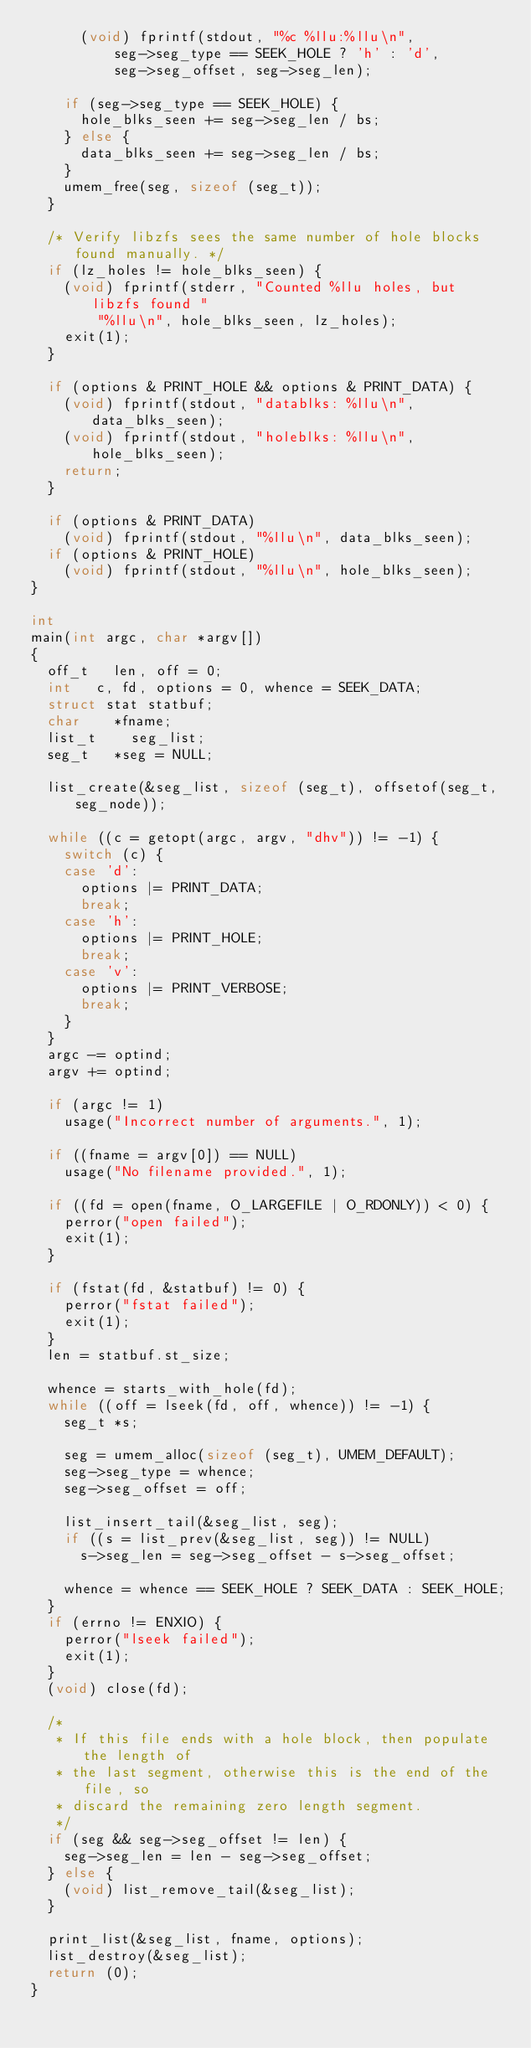<code> <loc_0><loc_0><loc_500><loc_500><_C_>			(void) fprintf(stdout, "%c %llu:%llu\n",
			    seg->seg_type == SEEK_HOLE ? 'h' : 'd',
			    seg->seg_offset, seg->seg_len);

		if (seg->seg_type == SEEK_HOLE) {
			hole_blks_seen += seg->seg_len / bs;
		} else {
			data_blks_seen += seg->seg_len / bs;
		}
		umem_free(seg, sizeof (seg_t));
	}

	/* Verify libzfs sees the same number of hole blocks found manually. */
	if (lz_holes != hole_blks_seen) {
		(void) fprintf(stderr, "Counted %llu holes, but libzfs found "
		    "%llu\n", hole_blks_seen, lz_holes);
		exit(1);
	}

	if (options & PRINT_HOLE && options & PRINT_DATA) {
		(void) fprintf(stdout, "datablks: %llu\n", data_blks_seen);
		(void) fprintf(stdout, "holeblks: %llu\n", hole_blks_seen);
		return;
	}

	if (options & PRINT_DATA)
		(void) fprintf(stdout, "%llu\n", data_blks_seen);
	if (options & PRINT_HOLE)
		(void) fprintf(stdout, "%llu\n", hole_blks_seen);
}

int
main(int argc, char *argv[])
{
	off_t		len, off = 0;
	int		c, fd, options = 0, whence = SEEK_DATA;
	struct stat	statbuf;
	char		*fname;
	list_t		seg_list;
	seg_t		*seg = NULL;

	list_create(&seg_list, sizeof (seg_t), offsetof(seg_t, seg_node));

	while ((c = getopt(argc, argv, "dhv")) != -1) {
		switch (c) {
		case 'd':
			options |= PRINT_DATA;
			break;
		case 'h':
			options |= PRINT_HOLE;
			break;
		case 'v':
			options |= PRINT_VERBOSE;
			break;
		}
	}
	argc -= optind;
	argv += optind;

	if (argc != 1)
		usage("Incorrect number of arguments.", 1);

	if ((fname = argv[0]) == NULL)
		usage("No filename provided.", 1);

	if ((fd = open(fname, O_LARGEFILE | O_RDONLY)) < 0) {
		perror("open failed");
		exit(1);
	}

	if (fstat(fd, &statbuf) != 0) {
		perror("fstat failed");
		exit(1);
	}
	len = statbuf.st_size;

	whence = starts_with_hole(fd);
	while ((off = lseek(fd, off, whence)) != -1) {
		seg_t	*s;

		seg = umem_alloc(sizeof (seg_t), UMEM_DEFAULT);
		seg->seg_type = whence;
		seg->seg_offset = off;

		list_insert_tail(&seg_list, seg);
		if ((s = list_prev(&seg_list, seg)) != NULL)
			s->seg_len = seg->seg_offset - s->seg_offset;

		whence = whence == SEEK_HOLE ? SEEK_DATA : SEEK_HOLE;
	}
	if (errno != ENXIO) {
		perror("lseek failed");
		exit(1);
	}
	(void) close(fd);

	/*
	 * If this file ends with a hole block, then populate the length of
	 * the last segment, otherwise this is the end of the file, so
	 * discard the remaining zero length segment.
	 */
	if (seg && seg->seg_offset != len) {
		seg->seg_len = len - seg->seg_offset;
	} else {
		(void) list_remove_tail(&seg_list);
	}

	print_list(&seg_list, fname, options);
	list_destroy(&seg_list);
	return (0);
}
</code> 